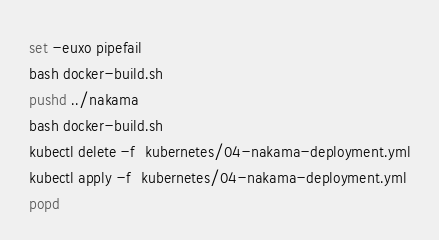<code> <loc_0><loc_0><loc_500><loc_500><_Bash_>set -euxo pipefail 
bash docker-build.sh 
pushd ../nakama
bash docker-build.sh
kubectl delete -f  kubernetes/04-nakama-deployment.yml
kubectl apply -f  kubernetes/04-nakama-deployment.yml
popd
</code> 